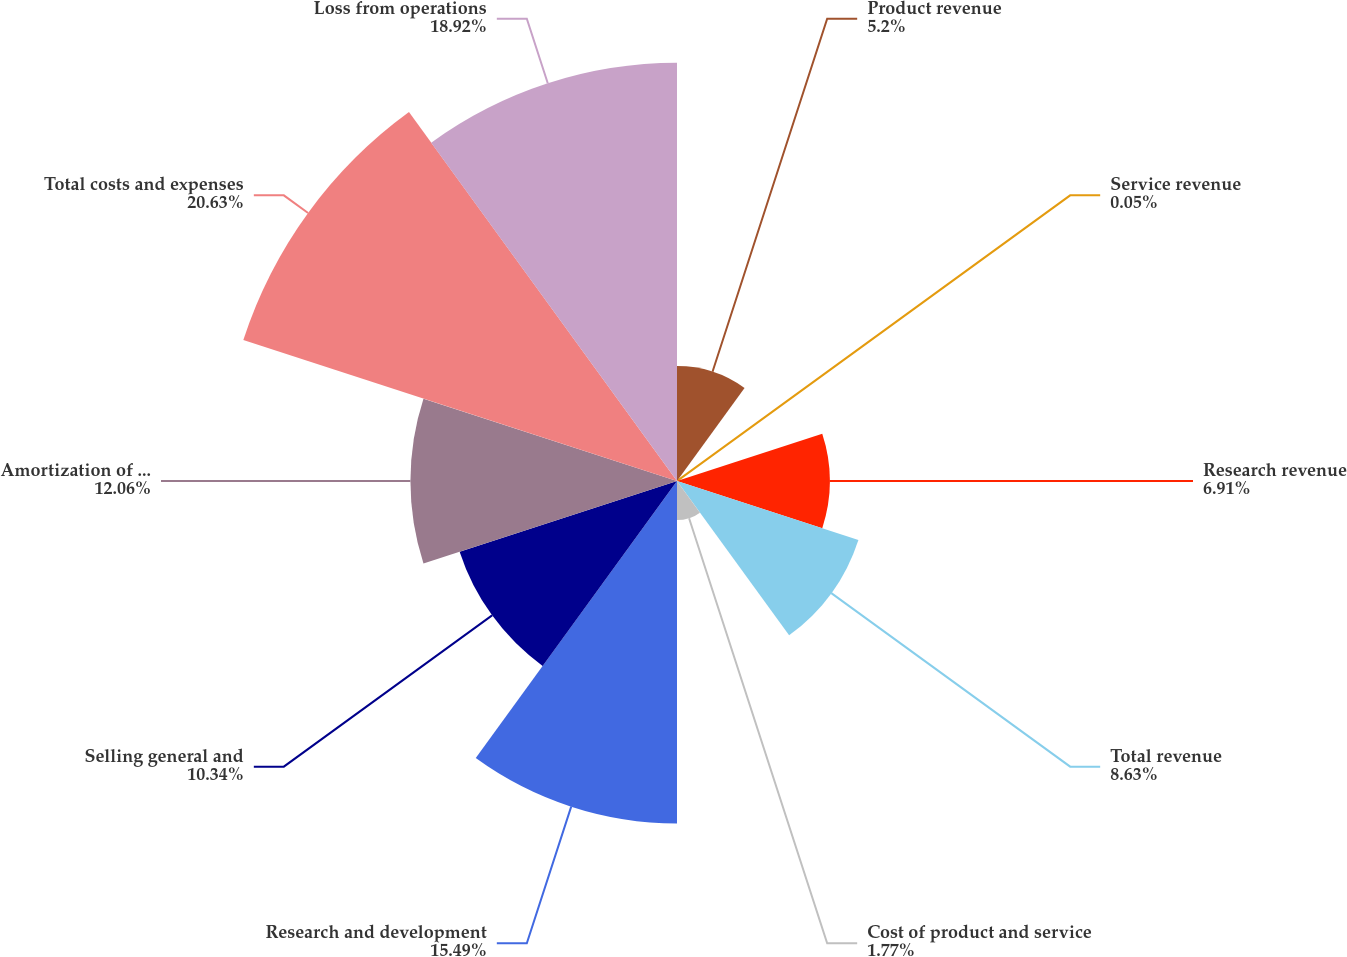Convert chart to OTSL. <chart><loc_0><loc_0><loc_500><loc_500><pie_chart><fcel>Product revenue<fcel>Service revenue<fcel>Research revenue<fcel>Total revenue<fcel>Cost of product and service<fcel>Research and development<fcel>Selling general and<fcel>Amortization of deferred<fcel>Total costs and expenses<fcel>Loss from operations<nl><fcel>5.2%<fcel>0.05%<fcel>6.91%<fcel>8.63%<fcel>1.77%<fcel>15.49%<fcel>10.34%<fcel>12.06%<fcel>20.63%<fcel>18.92%<nl></chart> 